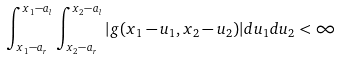Convert formula to latex. <formula><loc_0><loc_0><loc_500><loc_500>\int _ { x _ { 1 } - a _ { r } } ^ { x _ { 1 } - a _ { l } } \int _ { x _ { 2 } - a _ { r } } ^ { x _ { 2 } - a _ { l } } | g ( x _ { 1 } - u _ { 1 } , x _ { 2 } - u _ { 2 } ) | d u _ { 1 } d u _ { 2 } < \infty</formula> 